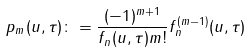Convert formula to latex. <formula><loc_0><loc_0><loc_500><loc_500>p _ { m } ( u , \tau ) \colon = \frac { ( - 1 ) ^ { m + 1 } } { f _ { n } ( u , \tau ) m ! } f _ { n } ^ { ( m - 1 ) } ( u , \tau )</formula> 